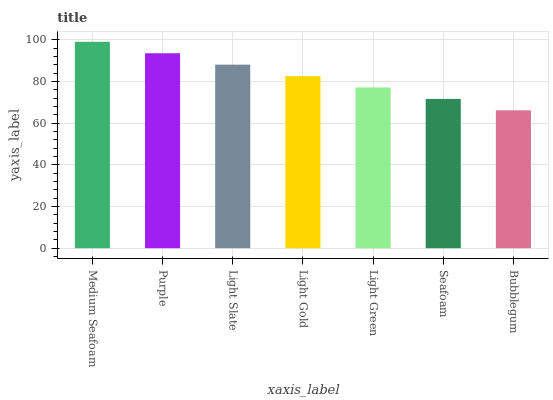Is Bubblegum the minimum?
Answer yes or no. Yes. Is Medium Seafoam the maximum?
Answer yes or no. Yes. Is Purple the minimum?
Answer yes or no. No. Is Purple the maximum?
Answer yes or no. No. Is Medium Seafoam greater than Purple?
Answer yes or no. Yes. Is Purple less than Medium Seafoam?
Answer yes or no. Yes. Is Purple greater than Medium Seafoam?
Answer yes or no. No. Is Medium Seafoam less than Purple?
Answer yes or no. No. Is Light Gold the high median?
Answer yes or no. Yes. Is Light Gold the low median?
Answer yes or no. Yes. Is Light Green the high median?
Answer yes or no. No. Is Light Slate the low median?
Answer yes or no. No. 